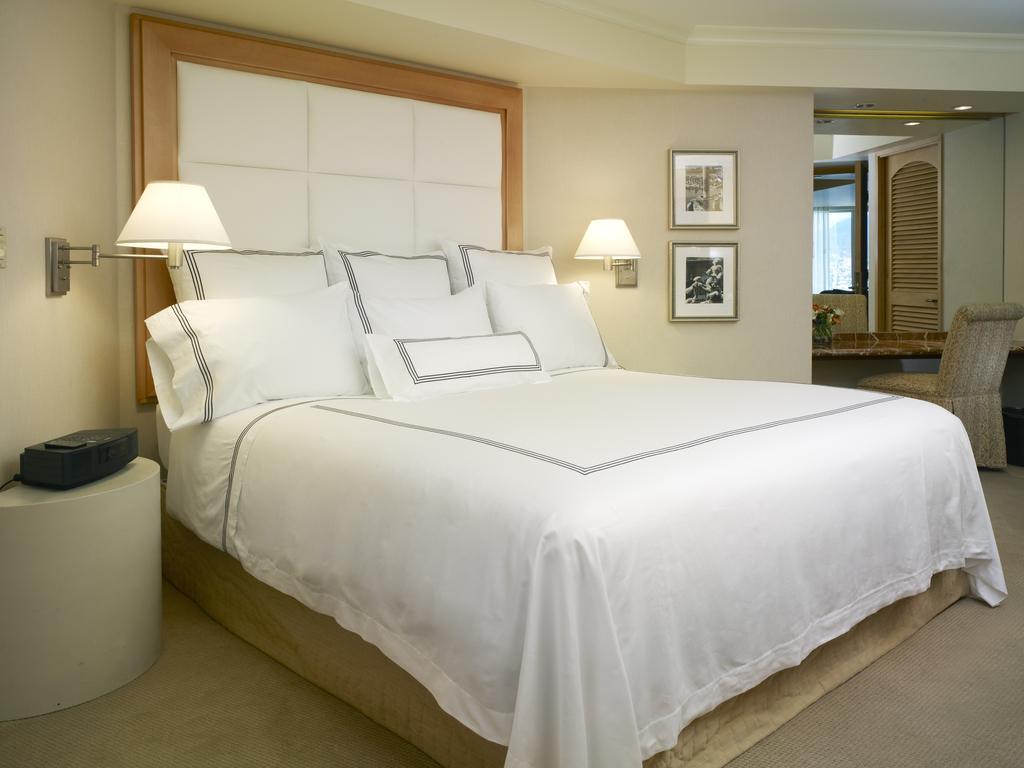Please provide a concise description of this image. In a room there is a bed with white color bed sheet on it. And with seven pillows. To both the side of the bed there are lamps. To the left side there is a table with DVD player on it. And to the right side there is a sofa and to the wall there are two frames. And in the middle there is a door. 